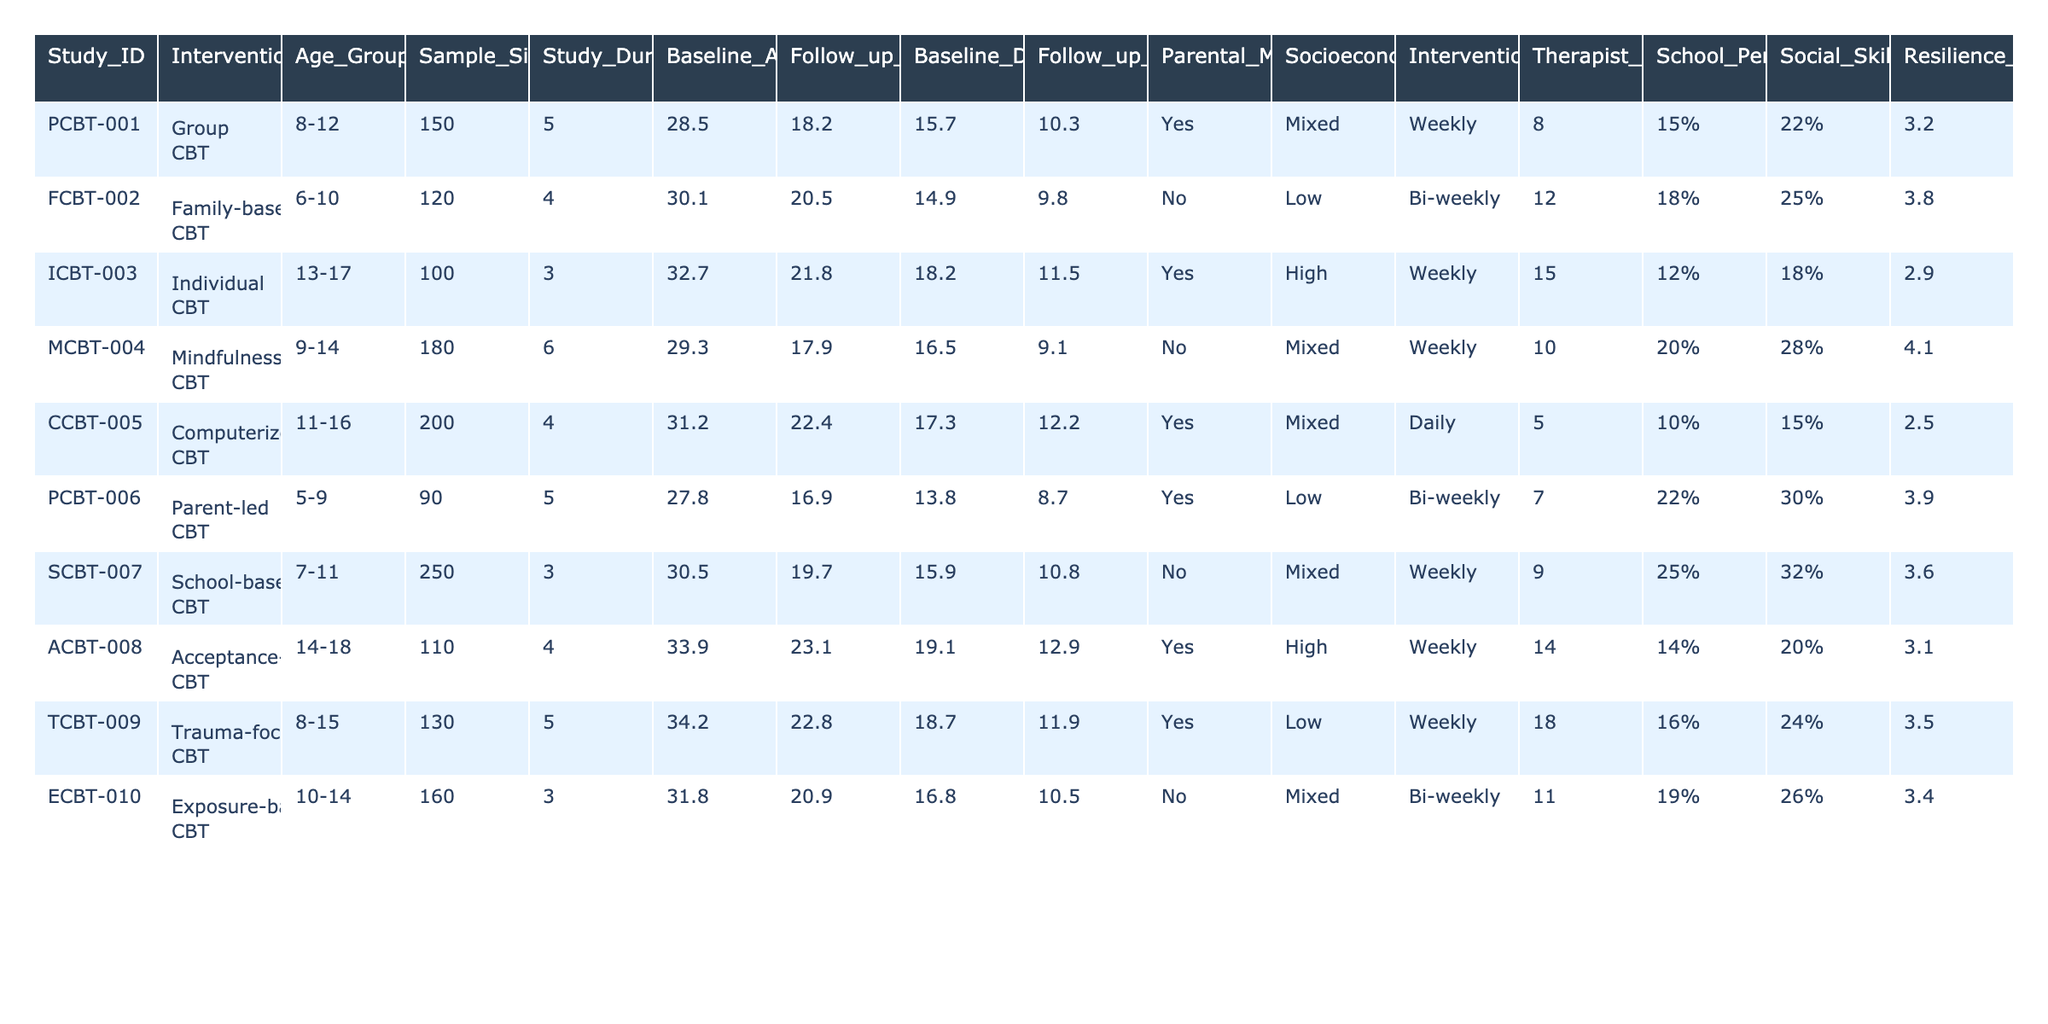What is the sample size of the Individual CBT study? The Individual CBT study has a sample size listed in the table, specifically in the 'Sample_Size' column corresponding to the 'ICBT-003' row. The value there is 100.
Answer: 100 Which intervention type had the highest improvement in school performance? To find this, look at the 'School_Performance_Improvement' column. The highest percentage is 25%, which corresponds to the School-based CBT intervention ('SCBT-007').
Answer: School-based CBT Is there a relationship between parental mental health history and the follow-up anxiety scores? To examine this, we can compare follow-up anxiety scores for studies with and without parental mental health history. Studies with a history (PCBT-001, ICBT-003, PCBT-006, ACBT-008, TCBT-009) have lower scores (average 17.6) compared to those without (FCBT-002, MCBT-004, CCBT-005, SCBT-007, ECBT-010) with an average of 21.5.
Answer: Yes, a relationship exists What is the average follow-up depression score of the Family-based CBT intervention? The follow-up depression score for the Family-based CBT is found in the 'Follow_up_Depression_Score' column for 'FCBT-002', which is 9.8. Since this is the only score for that intervention, it serves as the average.
Answer: 9.8 Which age group had the lowest baseline anxiety score and what was the score? Check the 'Age_Group' column alongside the 'Baseline_Anxiety_Score'. The age group 5-9 (PCBT-006) had the lowest baseline score of 27.8.
Answer: 5-9; 27.8 What is the difference in the resilience score improvements between the Group CBT and School-based CBT? The resilience score improvement for Group CBT (PCBT-001) is 3.2, and for School-based CBT (SCBT-007), it's 3.6. The difference is calculated as 3.6 - 3.2 = 0.4.
Answer: 0.4 Does any intervention with a low socioeconomic status have an improvement in social skills that exceeded 30%? By examining the 'Socioeconomic_Status' column and comparing it with 'Social_Skills_Improvement', the Parent-led CBT intervention (PCBT-006) with low socioeconomic status has a 30% improvement, meeting the condition.
Answer: Yes Which intervention had the longest duration and what was the improvement seen in resilience scores? The intervention with the longest duration is MCBT-004, which was 6 years long, and it had a resilience score improvement of 4.1.
Answer: 6 years; 4.1 Calculate the average therapist experience years for interventions with a weekly frequency. Reviewing the 'Therapist_Experience_Years' of interventions with a weekly frequency (PCBT-001, ICBT-003, MCBT-004, SCBT-007, TCBT-009), the years are 8, 15, 10, 9, and 18 respectively. Their average is (8 + 15 + 10 + 9 + 18) / 5 = 12.
Answer: 12 Is there any intervention that is both family-based and offers a weekly intervention frequency? Looking into the 'Intervention_Type' and 'Intervention_Frequency', Family-based CBT (FCBT-002) has a bi-weekly frequency, thus there isn't any intervention that meets both criteria.
Answer: No 